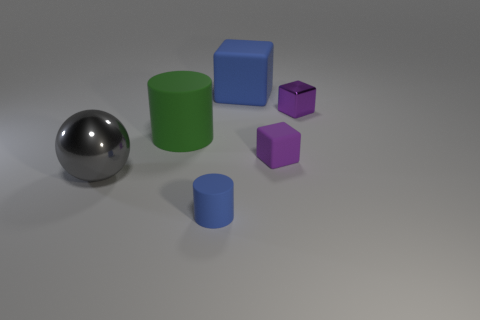How many balls are either tiny purple metal objects or big blue matte objects? In the image, there are no balls that are either tiny purple metal objects or big blue matte objects. There is one large metallic ball, but it is not purple, and there are no big blue matte balls present. 